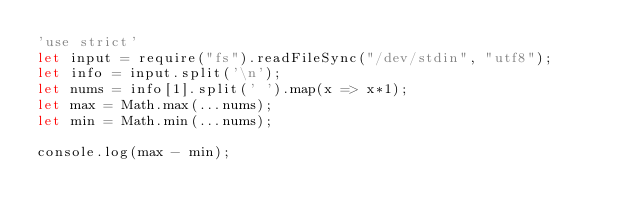Convert code to text. <code><loc_0><loc_0><loc_500><loc_500><_JavaScript_>'use strict'
let input = require("fs").readFileSync("/dev/stdin", "utf8");
let info = input.split('\n');
let nums = info[1].split(' ').map(x => x*1);
let max = Math.max(...nums);
let min = Math.min(...nums);

console.log(max - min);</code> 